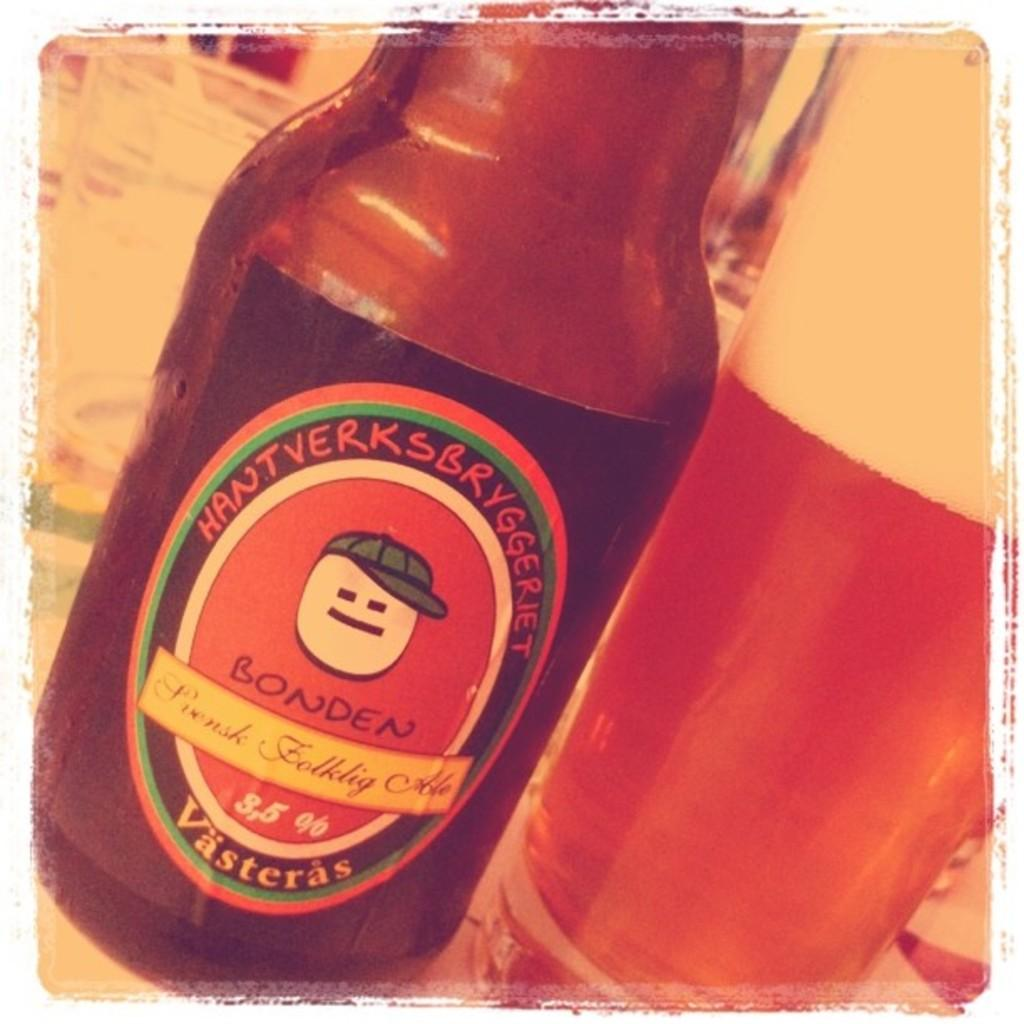<image>
Offer a succinct explanation of the picture presented. A Bonden brand bottle of beer sitting next to a pint glass. 